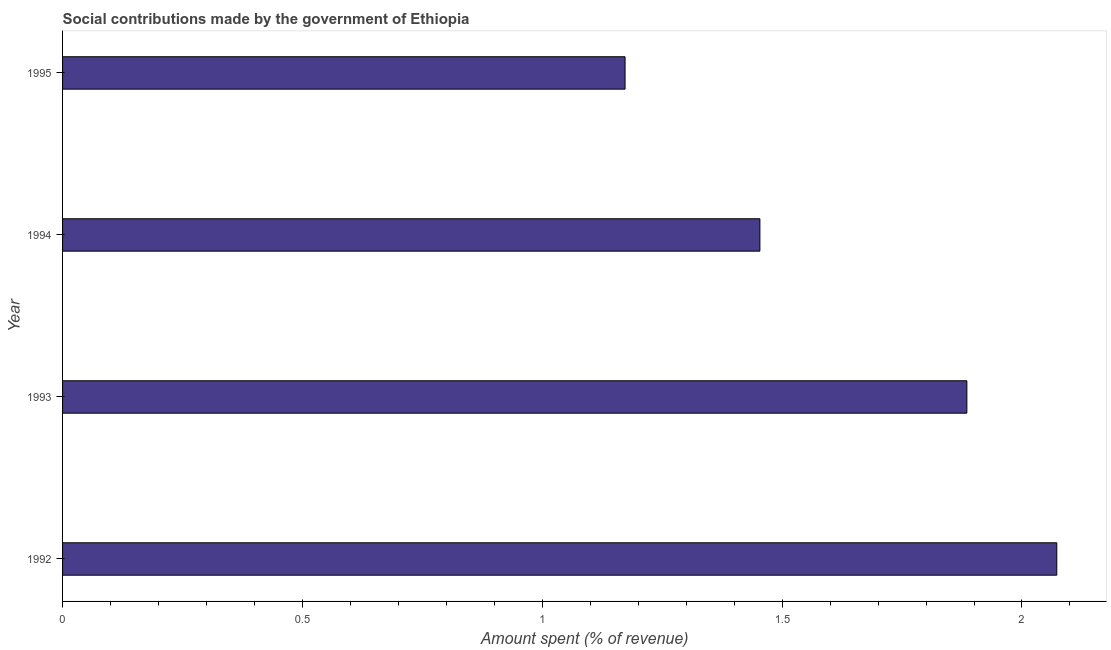What is the title of the graph?
Keep it short and to the point. Social contributions made by the government of Ethiopia. What is the label or title of the X-axis?
Keep it short and to the point. Amount spent (% of revenue). What is the amount spent in making social contributions in 1992?
Give a very brief answer. 2.07. Across all years, what is the maximum amount spent in making social contributions?
Offer a very short reply. 2.07. Across all years, what is the minimum amount spent in making social contributions?
Give a very brief answer. 1.17. What is the sum of the amount spent in making social contributions?
Give a very brief answer. 6.58. What is the difference between the amount spent in making social contributions in 1992 and 1993?
Your response must be concise. 0.19. What is the average amount spent in making social contributions per year?
Your response must be concise. 1.65. What is the median amount spent in making social contributions?
Your answer should be compact. 1.67. Do a majority of the years between 1993 and 1992 (inclusive) have amount spent in making social contributions greater than 1.6 %?
Keep it short and to the point. No. What is the ratio of the amount spent in making social contributions in 1992 to that in 1995?
Offer a terse response. 1.77. Is the amount spent in making social contributions in 1992 less than that in 1994?
Your answer should be compact. No. Is the difference between the amount spent in making social contributions in 1992 and 1993 greater than the difference between any two years?
Your response must be concise. No. What is the difference between the highest and the second highest amount spent in making social contributions?
Provide a succinct answer. 0.19. Is the sum of the amount spent in making social contributions in 1992 and 1994 greater than the maximum amount spent in making social contributions across all years?
Keep it short and to the point. Yes. What is the difference between the highest and the lowest amount spent in making social contributions?
Your answer should be compact. 0.9. Are all the bars in the graph horizontal?
Your response must be concise. Yes. How many years are there in the graph?
Your response must be concise. 4. What is the Amount spent (% of revenue) in 1992?
Provide a succinct answer. 2.07. What is the Amount spent (% of revenue) in 1993?
Provide a succinct answer. 1.89. What is the Amount spent (% of revenue) of 1994?
Your answer should be compact. 1.45. What is the Amount spent (% of revenue) of 1995?
Your answer should be very brief. 1.17. What is the difference between the Amount spent (% of revenue) in 1992 and 1993?
Your answer should be compact. 0.19. What is the difference between the Amount spent (% of revenue) in 1992 and 1994?
Provide a short and direct response. 0.62. What is the difference between the Amount spent (% of revenue) in 1992 and 1995?
Your answer should be compact. 0.9. What is the difference between the Amount spent (% of revenue) in 1993 and 1994?
Make the answer very short. 0.43. What is the difference between the Amount spent (% of revenue) in 1993 and 1995?
Provide a succinct answer. 0.71. What is the difference between the Amount spent (% of revenue) in 1994 and 1995?
Make the answer very short. 0.28. What is the ratio of the Amount spent (% of revenue) in 1992 to that in 1993?
Provide a short and direct response. 1.1. What is the ratio of the Amount spent (% of revenue) in 1992 to that in 1994?
Ensure brevity in your answer.  1.43. What is the ratio of the Amount spent (% of revenue) in 1992 to that in 1995?
Your answer should be compact. 1.77. What is the ratio of the Amount spent (% of revenue) in 1993 to that in 1994?
Give a very brief answer. 1.3. What is the ratio of the Amount spent (% of revenue) in 1993 to that in 1995?
Your answer should be compact. 1.61. What is the ratio of the Amount spent (% of revenue) in 1994 to that in 1995?
Make the answer very short. 1.24. 